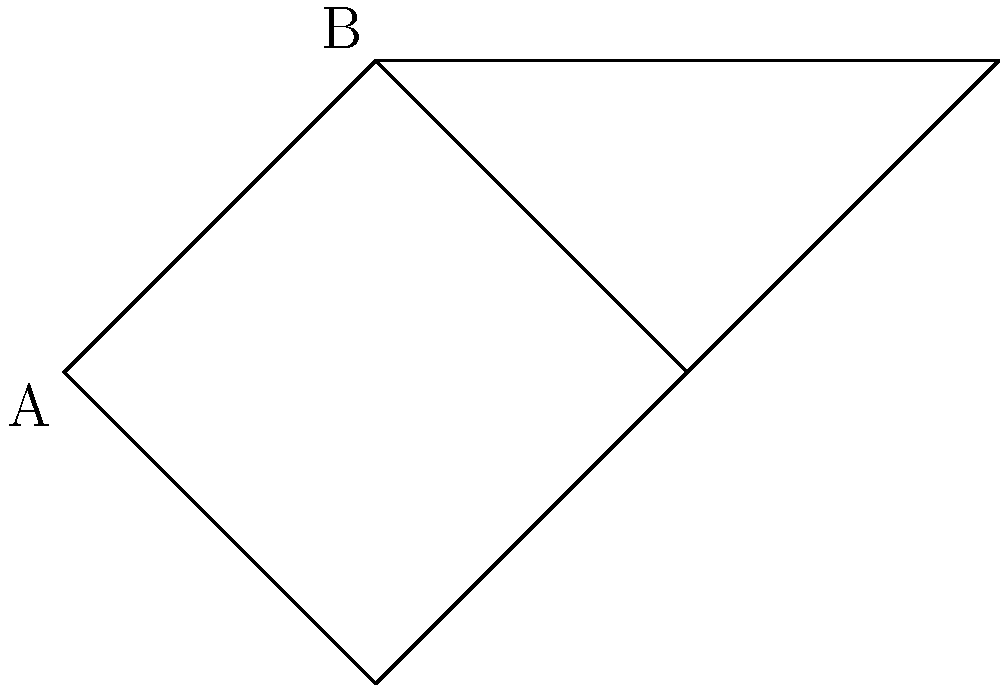In the network topology graph shown above, a data packet needs to be transmitted from node A to node C. What is the minimum total weight of the path the packet should take to reach its destination most efficiently? To find the minimum total weight of the path from A to C, we need to consider all possible paths and their weights:

1. Path A → B → C:
   Weight = 5 + 3 = 8

2. Path A → B → E → C:
   Weight = 5 + 1 + 2 = 8

3. Path A → D → C:
   Weight = 4 + 2 = 6

The path A → D → C has the minimum total weight of 6, making it the most efficient route for the data packet to travel from A to C.

This problem is relevant to the persona of a software hacker because understanding network topologies and efficient data transmission paths is crucial for intercepting and manipulating data packets in virtual reality content.
Answer: 6 